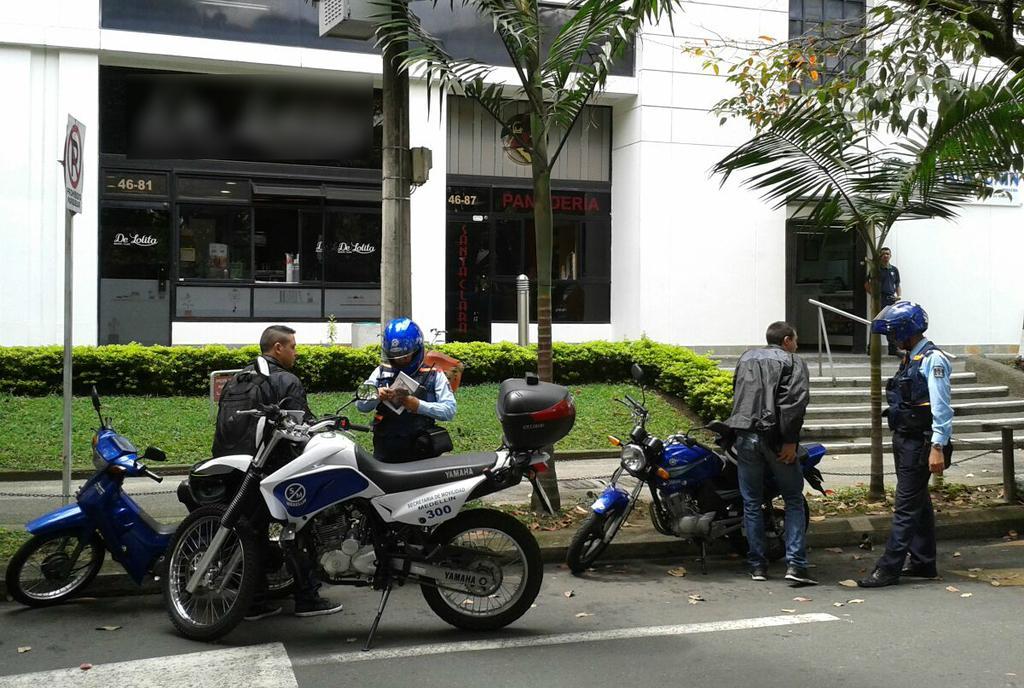Can you describe this image briefly? In this image there are bikes on the road. There are people standing on the road. Right side there is a person wearing a helmet. Middle of the image there is a person wearing a helmet and he is holding an object. Right side there is a staircase. Left there is a board attached to the pole. There is a pole on the pavement having trees. There are plants on the grassland. Background there is a building. Right side a person is standing on the floor. 